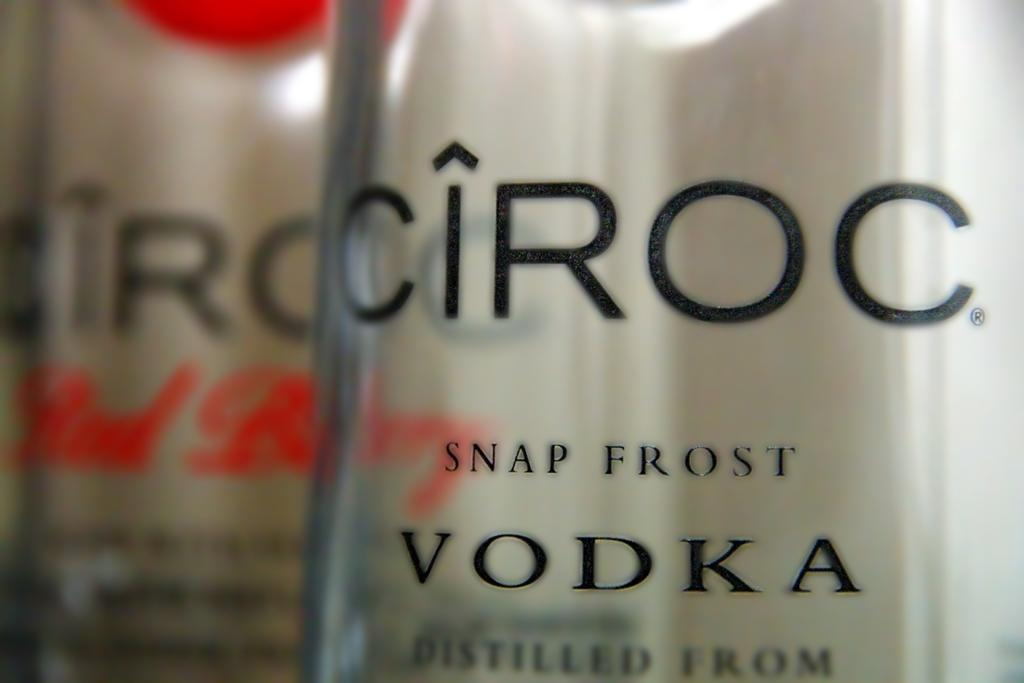<image>
Provide a brief description of the given image. Bottle of alcohol that says Vodka on it. 